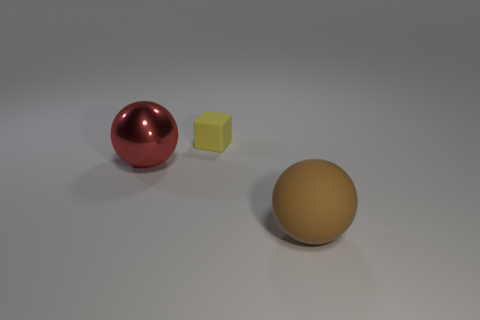Subtract 1 balls. How many balls are left? 1 Add 3 small brown cubes. How many objects exist? 6 Subtract all brown balls. How many balls are left? 1 Add 3 red shiny balls. How many red shiny balls exist? 4 Subtract 0 yellow cylinders. How many objects are left? 3 Subtract all spheres. How many objects are left? 1 Subtract all gray cubes. Subtract all red cylinders. How many cubes are left? 1 Subtract all red cubes. How many cyan balls are left? 0 Subtract all small yellow cubes. Subtract all yellow blocks. How many objects are left? 1 Add 2 rubber objects. How many rubber objects are left? 4 